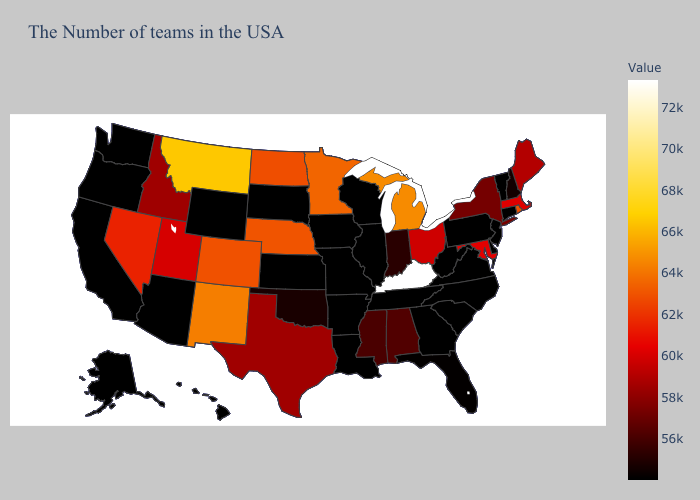Which states hav the highest value in the South?
Concise answer only. Kentucky. Among the states that border North Dakota , which have the lowest value?
Quick response, please. South Dakota. Among the states that border California , does Oregon have the highest value?
Concise answer only. No. Among the states that border Iowa , does Minnesota have the highest value?
Answer briefly. Yes. Which states have the highest value in the USA?
Concise answer only. Kentucky. 